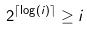<formula> <loc_0><loc_0><loc_500><loc_500>2 ^ { \lceil \log ( i ) \rceil } \geq i</formula> 